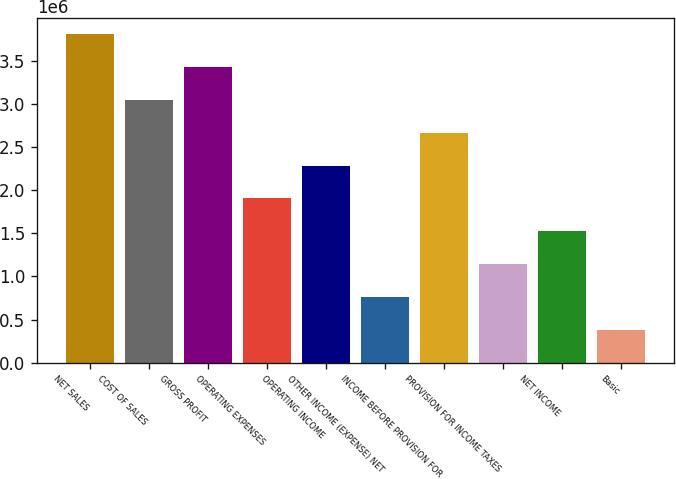Convert chart. <chart><loc_0><loc_0><loc_500><loc_500><bar_chart><fcel>NET SALES<fcel>COST OF SALES<fcel>GROSS PROFIT<fcel>OPERATING EXPENSES<fcel>OPERATING INCOME<fcel>OTHER INCOME (EXPENSE) NET<fcel>INCOME BEFORE PROVISION FOR<fcel>PROVISION FOR INCOME TAXES<fcel>NET INCOME<fcel>Basic<nl><fcel>3.80718e+06<fcel>3.04575e+06<fcel>3.42646e+06<fcel>1.90359e+06<fcel>2.28431e+06<fcel>761438<fcel>2.66503e+06<fcel>1.14216e+06<fcel>1.52287e+06<fcel>380720<nl></chart> 